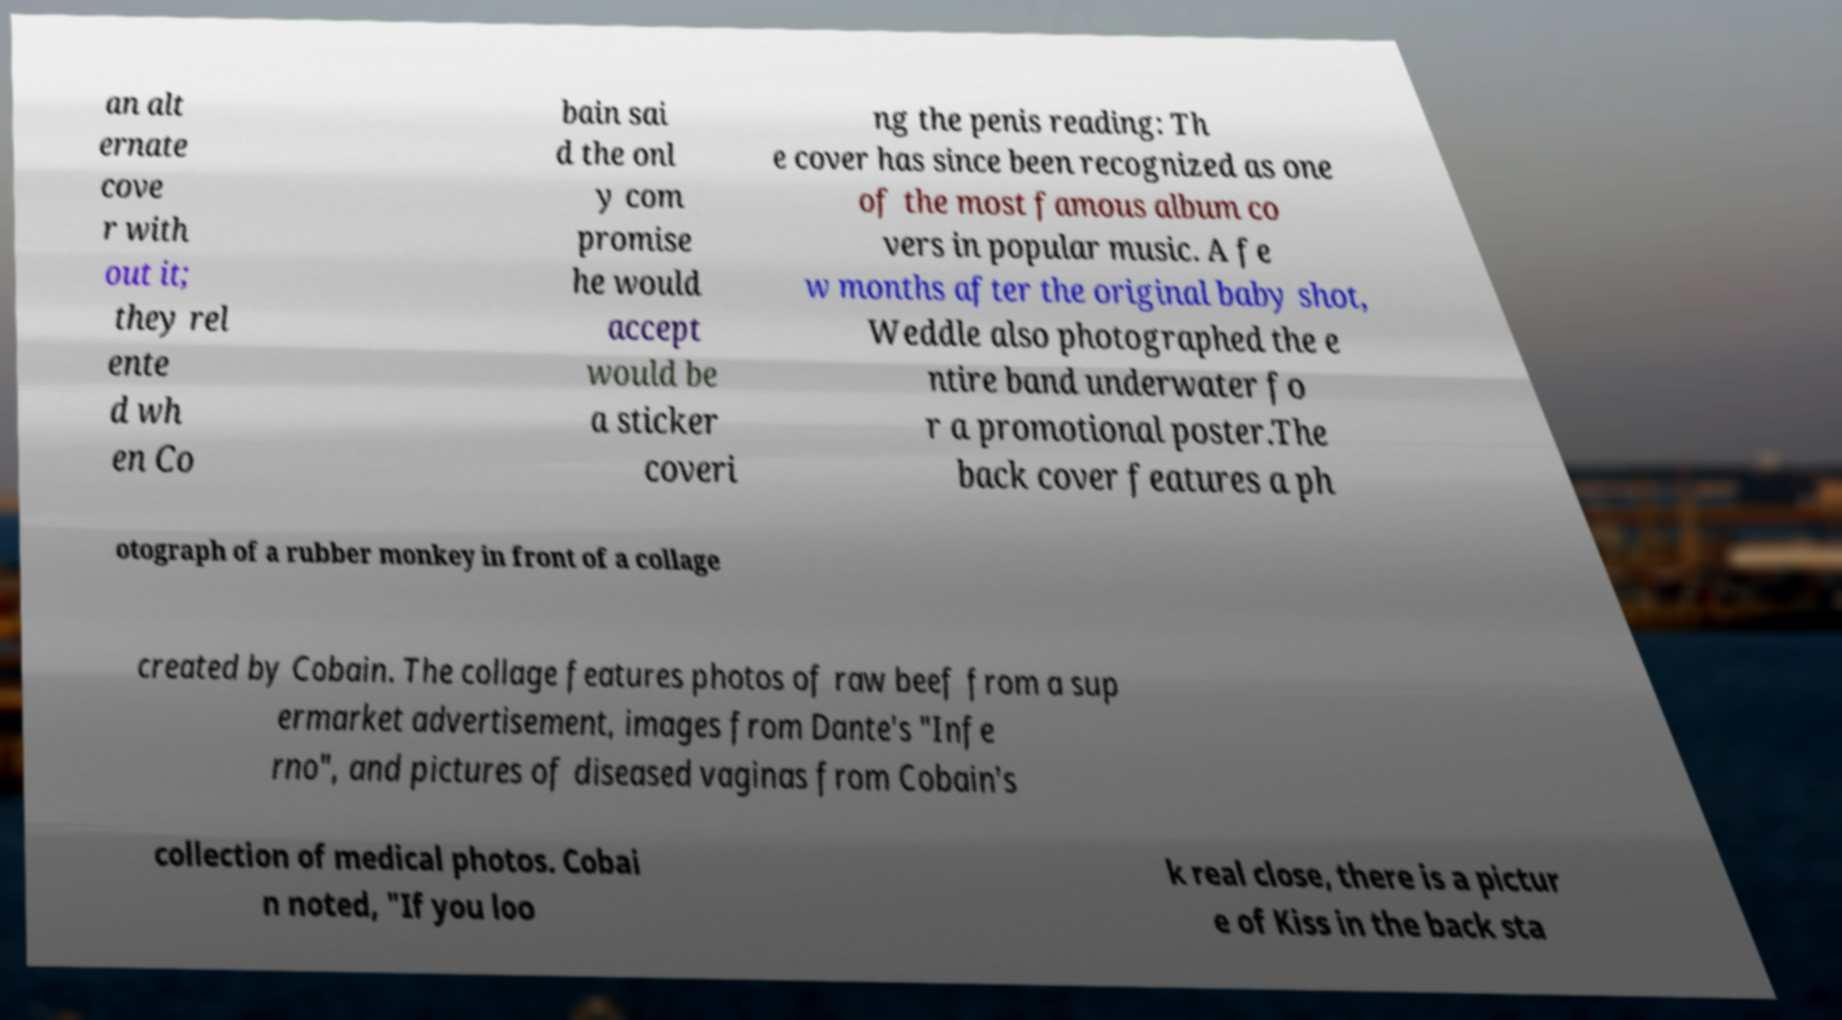Can you read and provide the text displayed in the image?This photo seems to have some interesting text. Can you extract and type it out for me? an alt ernate cove r with out it; they rel ente d wh en Co bain sai d the onl y com promise he would accept would be a sticker coveri ng the penis reading: Th e cover has since been recognized as one of the most famous album co vers in popular music. A fe w months after the original baby shot, Weddle also photographed the e ntire band underwater fo r a promotional poster.The back cover features a ph otograph of a rubber monkey in front of a collage created by Cobain. The collage features photos of raw beef from a sup ermarket advertisement, images from Dante's "Infe rno", and pictures of diseased vaginas from Cobain's collection of medical photos. Cobai n noted, "If you loo k real close, there is a pictur e of Kiss in the back sta 